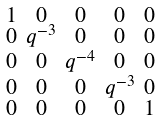<formula> <loc_0><loc_0><loc_500><loc_500>\begin{smallmatrix} 1 & 0 & 0 & 0 & 0 \\ 0 & q ^ { - 3 } & 0 & 0 & 0 \\ 0 & 0 & q ^ { - 4 } & 0 & 0 \\ 0 & 0 & 0 & q ^ { - 3 } & 0 \\ 0 & 0 & 0 & 0 & 1 \end{smallmatrix}</formula> 